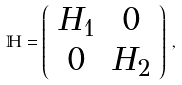<formula> <loc_0><loc_0><loc_500><loc_500>\mathbb { H } = \left ( \begin{array} { c c } H _ { 1 } & 0 \\ 0 & H _ { 2 } \end{array} \right ) \, ,</formula> 